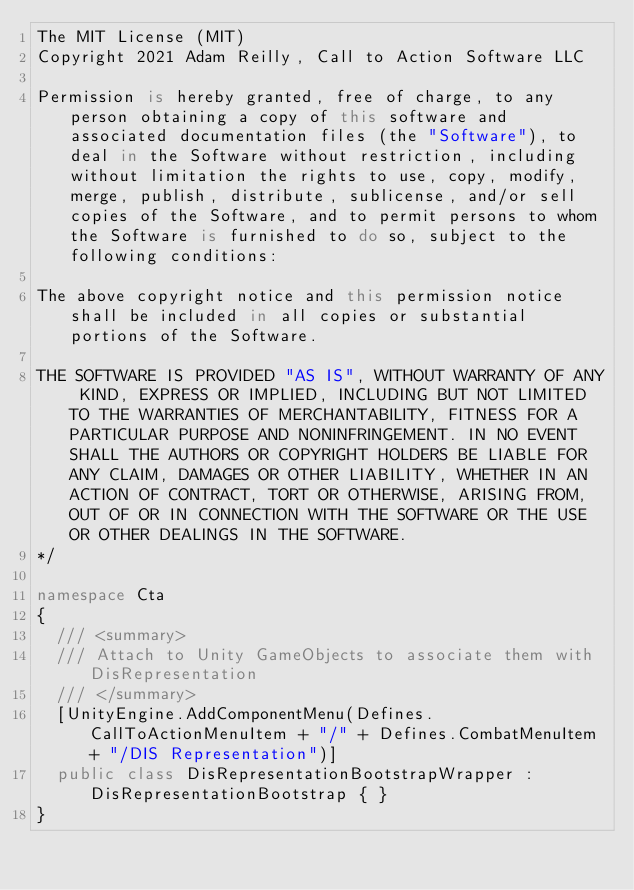Convert code to text. <code><loc_0><loc_0><loc_500><loc_500><_C#_>The MIT License (MIT)
Copyright 2021 Adam Reilly, Call to Action Software LLC

Permission is hereby granted, free of charge, to any person obtaining a copy of this software and associated documentation files (the "Software"), to deal in the Software without restriction, including without limitation the rights to use, copy, modify, merge, publish, distribute, sublicense, and/or sell copies of the Software, and to permit persons to whom the Software is furnished to do so, subject to the following conditions:

The above copyright notice and this permission notice shall be included in all copies or substantial portions of the Software.

THE SOFTWARE IS PROVIDED "AS IS", WITHOUT WARRANTY OF ANY KIND, EXPRESS OR IMPLIED, INCLUDING BUT NOT LIMITED TO THE WARRANTIES OF MERCHANTABILITY, FITNESS FOR A PARTICULAR PURPOSE AND NONINFRINGEMENT. IN NO EVENT SHALL THE AUTHORS OR COPYRIGHT HOLDERS BE LIABLE FOR ANY CLAIM, DAMAGES OR OTHER LIABILITY, WHETHER IN AN ACTION OF CONTRACT, TORT OR OTHERWISE, ARISING FROM, OUT OF OR IN CONNECTION WITH THE SOFTWARE OR THE USE OR OTHER DEALINGS IN THE SOFTWARE.
*/

namespace Cta
{
	/// <summary>
	/// Attach to Unity GameObjects to associate them with DisRepresentation
	/// </summary>
	[UnityEngine.AddComponentMenu(Defines.CallToActionMenuItem + "/" + Defines.CombatMenuItem + "/DIS Representation")]
	public class DisRepresentationBootstrapWrapper : DisRepresentationBootstrap { }
}
</code> 